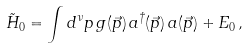Convert formula to latex. <formula><loc_0><loc_0><loc_500><loc_500>{ \tilde { H } } _ { 0 } = \int d ^ { \nu } p \, g ( \vec { p } ) \, a ^ { \dag } ( \vec { p } ) \, a ( \vec { p } ) + E _ { 0 } \, ,</formula> 